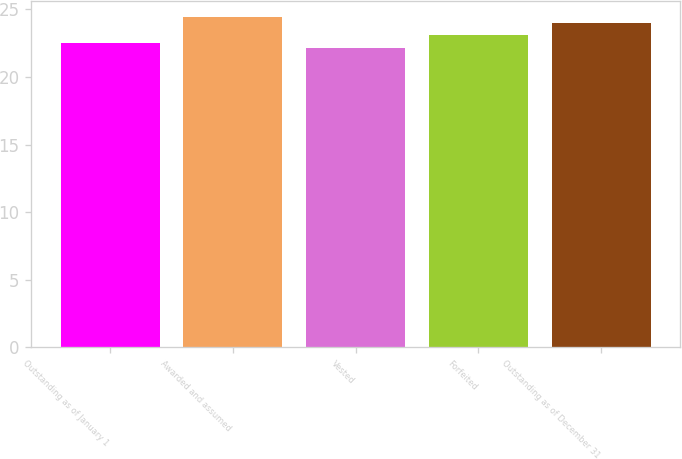<chart> <loc_0><loc_0><loc_500><loc_500><bar_chart><fcel>Outstanding as of January 1<fcel>Awarded and assumed<fcel>Vested<fcel>Forfeited<fcel>Outstanding as of December 31<nl><fcel>22.5<fcel>24.41<fcel>22.15<fcel>23.09<fcel>24<nl></chart> 